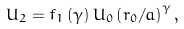<formula> <loc_0><loc_0><loc_500><loc_500>U _ { 2 } = f _ { 1 } \left ( \gamma \right ) U _ { 0 } \left ( r _ { 0 } / a \right ) ^ { \gamma } ,</formula> 